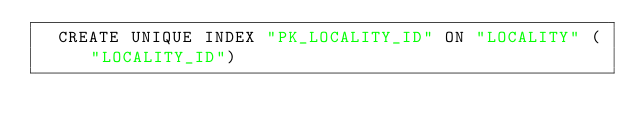Convert code to text. <code><loc_0><loc_0><loc_500><loc_500><_SQL_>  CREATE UNIQUE INDEX "PK_LOCALITY_ID" ON "LOCALITY" ("LOCALITY_ID") 
  </code> 